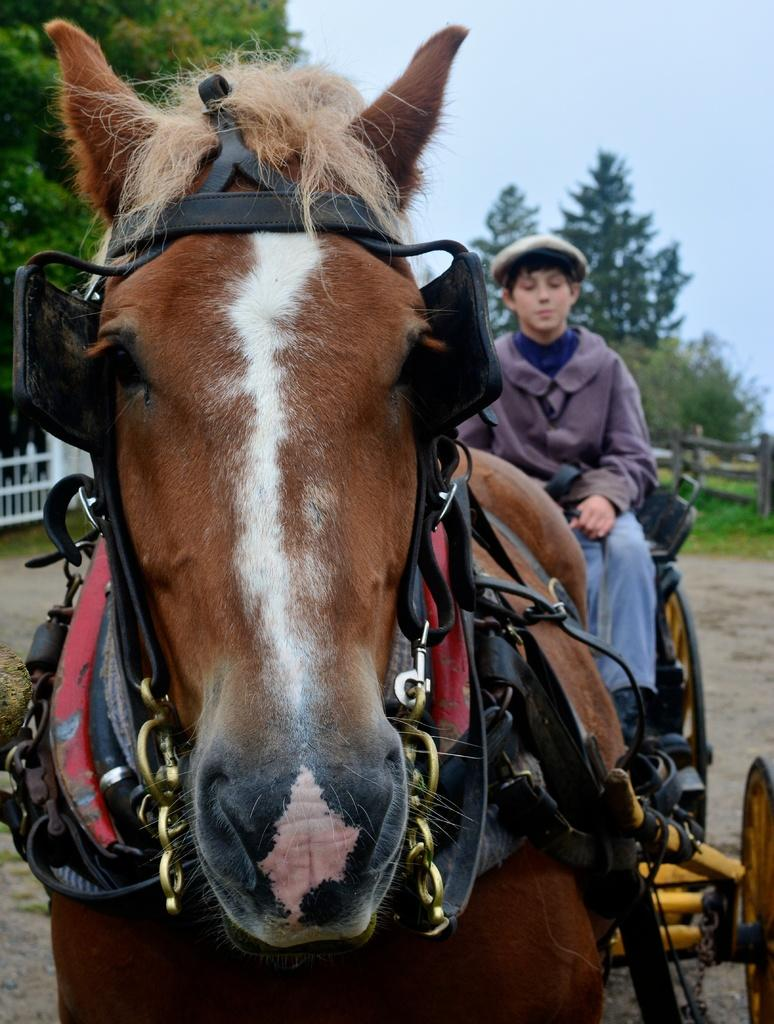What animal is present in the image? There is a horse in the image. Who is also present in the image? There is a boy in the image. What can be seen in the background of the image? There are trees and the sky visible in the background of the image. What type of oven can be seen in the image? There is no oven present in the image. Can you tell me the name of the lawyer in the image? There is no lawyer present in the image. 